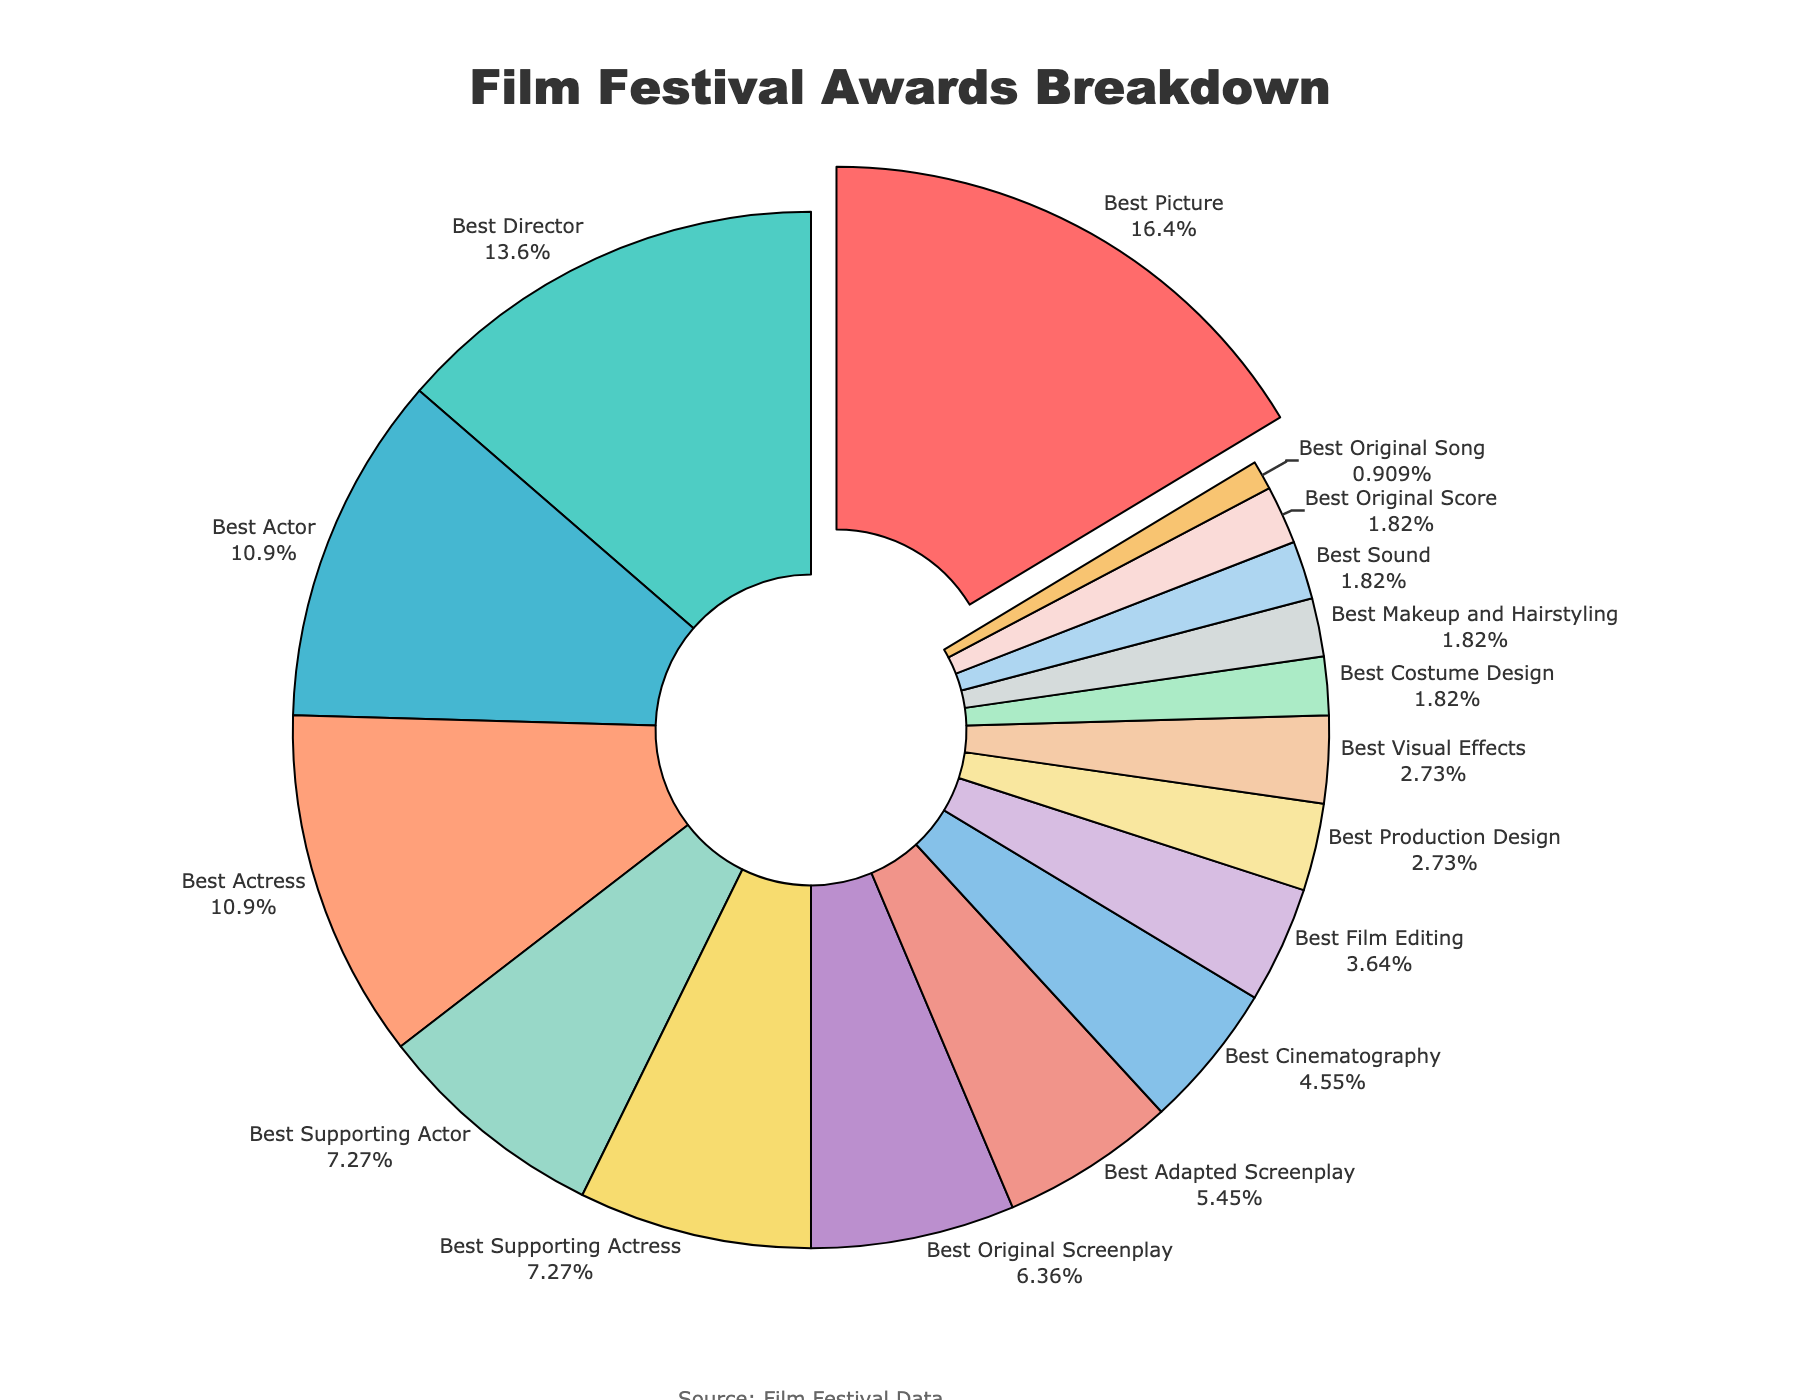What category has the highest percentage of awards? Looking at the pie chart, "Best Picture" stands out as having the largest portion of the pie, identifiable by its larger size and pulled-out segment.
Answer: Best Picture What is the combined percentage of awards for Best Actor and Best Actress categories? The percentage for Best Actor is 12% and for Best Actress is also 12%. Adding them together gives 12 + 12 = 24%.
Answer: 24% Which category has the smallest percentage of awards, and what is that percentage? By examining the pie chart, the smallest segment belongs to the "Best Original Song" category, which occupies 1% of the pie chart.
Answer: Best Original Song, 1% How do the percentages for Best Director and Best Original Screenplay compare? The pie chart shows that Best Director has 15% while Best Original Screenplay has 7%. Best Director has a higher percentage than Best Original Screenplay.
Answer: Best Director has a higher percentage Are there any categories with equal percentages for awards? Looking at the pie chart, the categories "Best Actor" and "Best Actress" both have 12%, and "Best Supporting Actor" and "Best Supporting Actress" each have 8%, indicating equal percentages.
Answer: Yes, Best Actor and Best Actress, Best Supporting Actor and Best Supporting Actress What is the total percentage for all screenplay-related categories? The categories "Best Original Screenplay" and "Best Adapted Screenplay" fall under screenplay-related awards with percentages of 7% and 6%, respectively. Summing these gives 7 + 6 = 13%.
Answer: 13% How does the percentage of Best Picture compare to the total of all acting categories combined (Best Actor, Best Actress, Best Supporting Actor, Best Supporting Actress)? Best Picture has 18%. Combining the acting categories: Best Actor (12%), Best Actress (12%), Best Supporting Actor (8%), and Best Supporting Actress (8%) gives 12 + 12 + 8 + 8 = 40%. Best Picture is less than the total of all acting categories combined.
Answer: Best Picture is less Which categories together comprise exactly 10% of the awards? On the pie chart, "Best Cinematography" (5%) and "Best Film Editing" (4%) combined give 9%, which is closest but not exactly 10%. "Best Adapted Screenplay" (6%) and "Best Costume Design" (2%) combined give 8%. Therefore, no single combination matches exactly 10%, though "Best Cinematography" and "Best Film Editing" are closest.
Answer: None Identify the categories represented by the smallest three percentages and add their values. The smallest three percentages are "Best Original Song" (1%), "Best Costume Design" (2%), and "Best Makeup and Hairstyling" (2%). Adding them: 1 + 2 + 2 = 5%.
Answer: 5% If Best Picture's percentage were to decrease by 3%, what would its new percentage be? The current percentage for Best Picture is 18%. Decreasing this by 3% gives 18 - 3 = 15%.
Answer: 15% 